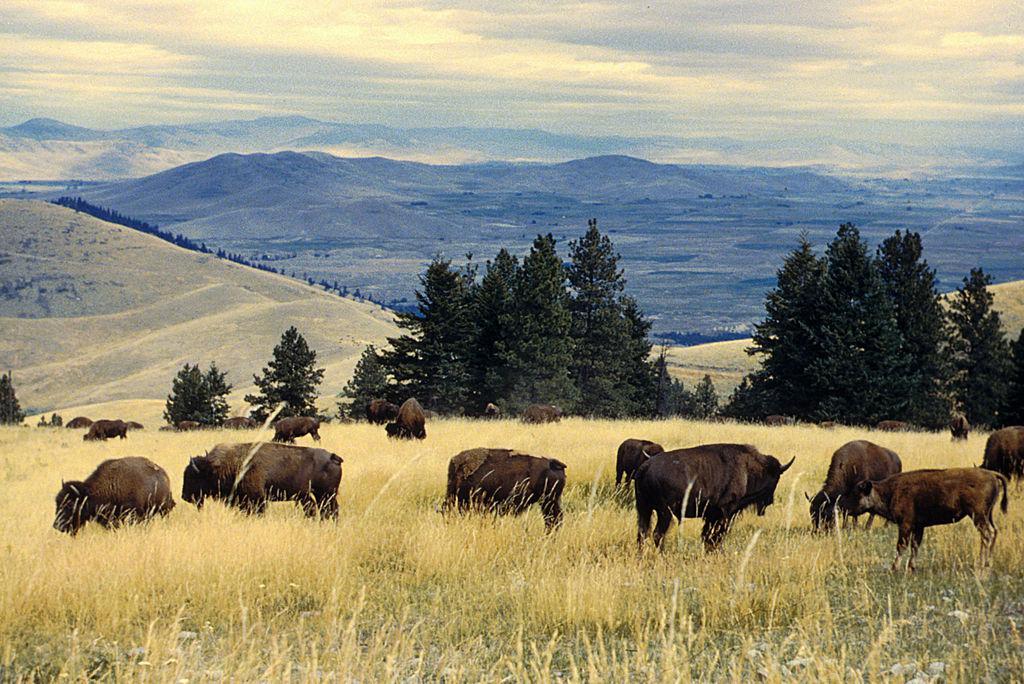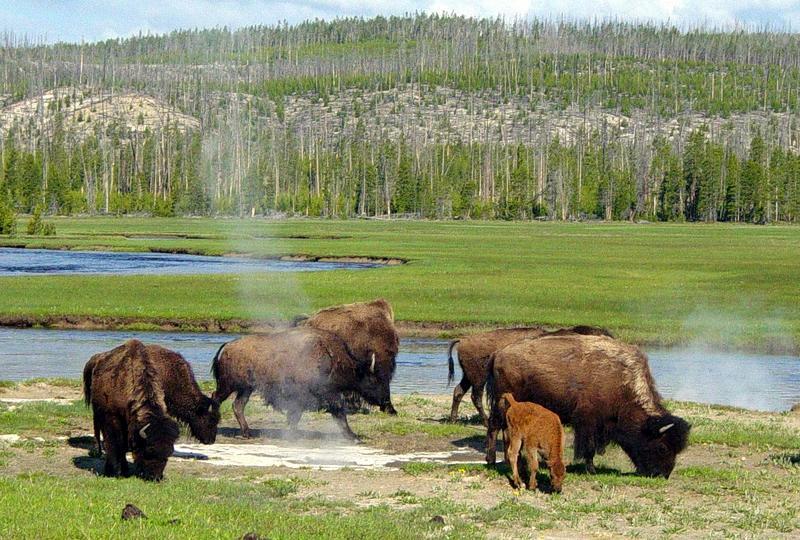The first image is the image on the left, the second image is the image on the right. Analyze the images presented: Is the assertion "In at least one image there are three bulls turned left grazing." valid? Answer yes or no. No. The first image is the image on the left, the second image is the image on the right. Analyze the images presented: Is the assertion "Several buffalo are standing in front of channels of water in a green field in one image." valid? Answer yes or no. Yes. 